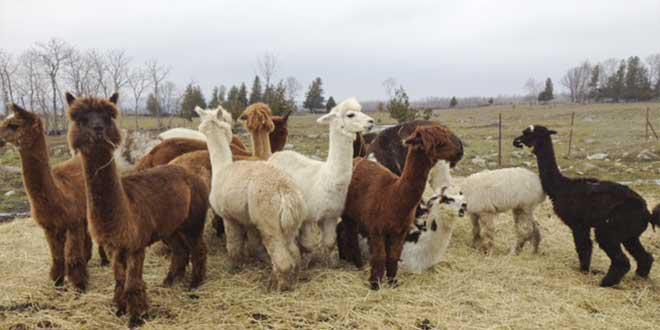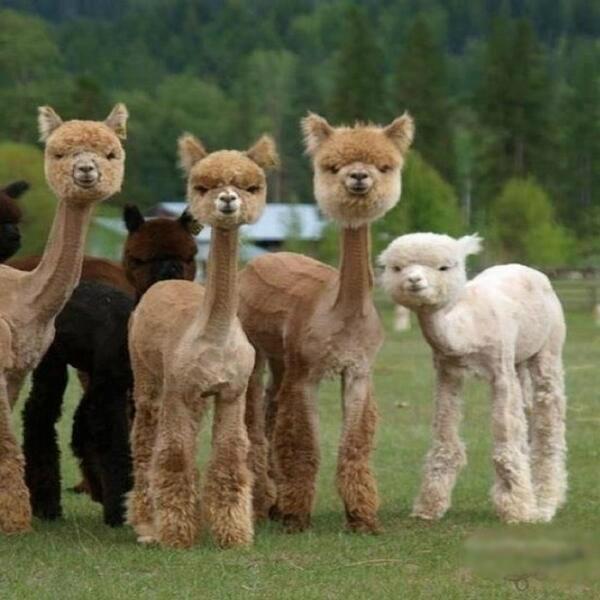The first image is the image on the left, the second image is the image on the right. Evaluate the accuracy of this statement regarding the images: "At least one photo shows an animal that has had the hair on its neck shaved, and every photo has at least three animals.". Is it true? Answer yes or no. Yes. The first image is the image on the left, the second image is the image on the right. Evaluate the accuracy of this statement regarding the images: "At least some of the llamas have shaved necks.". Is it true? Answer yes or no. Yes. 